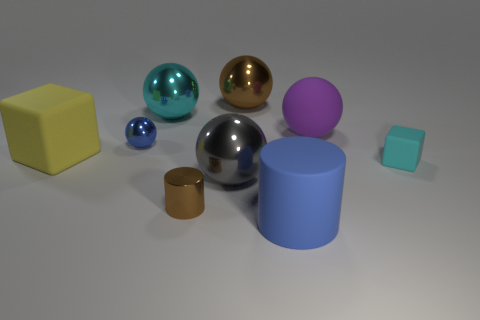Subtract all brown spheres. How many spheres are left? 4 Subtract all gray spheres. How many spheres are left? 4 Subtract 1 balls. How many balls are left? 4 Subtract all red spheres. Subtract all brown cylinders. How many spheres are left? 5 Add 1 big yellow blocks. How many objects exist? 10 Subtract all spheres. How many objects are left? 4 Add 6 purple things. How many purple things are left? 7 Add 7 large brown balls. How many large brown balls exist? 8 Subtract 1 yellow blocks. How many objects are left? 8 Subtract all large things. Subtract all tiny blue rubber objects. How many objects are left? 3 